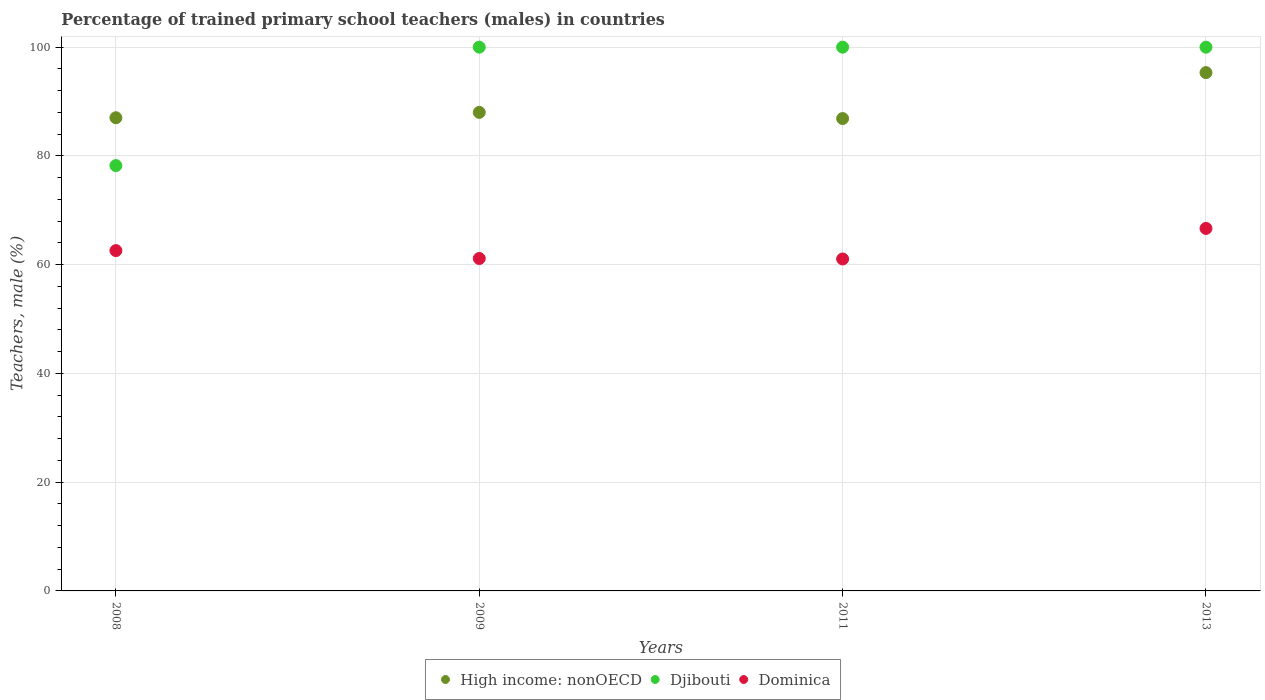Is the number of dotlines equal to the number of legend labels?
Your answer should be compact. Yes. What is the percentage of trained primary school teachers (males) in Dominica in 2008?
Make the answer very short. 62.59. Across all years, what is the maximum percentage of trained primary school teachers (males) in High income: nonOECD?
Give a very brief answer. 95.32. Across all years, what is the minimum percentage of trained primary school teachers (males) in Dominica?
Provide a short and direct response. 61.05. In which year was the percentage of trained primary school teachers (males) in Djibouti maximum?
Provide a succinct answer. 2009. In which year was the percentage of trained primary school teachers (males) in High income: nonOECD minimum?
Keep it short and to the point. 2011. What is the total percentage of trained primary school teachers (males) in High income: nonOECD in the graph?
Make the answer very short. 357.22. What is the difference between the percentage of trained primary school teachers (males) in High income: nonOECD in 2008 and that in 2009?
Provide a succinct answer. -0.99. What is the difference between the percentage of trained primary school teachers (males) in Dominica in 2011 and the percentage of trained primary school teachers (males) in High income: nonOECD in 2009?
Your response must be concise. -26.96. What is the average percentage of trained primary school teachers (males) in Dominica per year?
Ensure brevity in your answer.  62.86. In the year 2011, what is the difference between the percentage of trained primary school teachers (males) in Djibouti and percentage of trained primary school teachers (males) in High income: nonOECD?
Provide a succinct answer. 13.13. In how many years, is the percentage of trained primary school teachers (males) in Dominica greater than 52 %?
Provide a short and direct response. 4. What is the ratio of the percentage of trained primary school teachers (males) in High income: nonOECD in 2008 to that in 2011?
Your response must be concise. 1. What is the difference between the highest and the second highest percentage of trained primary school teachers (males) in Dominica?
Ensure brevity in your answer.  4.08. What is the difference between the highest and the lowest percentage of trained primary school teachers (males) in Dominica?
Offer a very short reply. 5.62. In how many years, is the percentage of trained primary school teachers (males) in Dominica greater than the average percentage of trained primary school teachers (males) in Dominica taken over all years?
Give a very brief answer. 1. Is it the case that in every year, the sum of the percentage of trained primary school teachers (males) in Dominica and percentage of trained primary school teachers (males) in High income: nonOECD  is greater than the percentage of trained primary school teachers (males) in Djibouti?
Your response must be concise. Yes. Is the percentage of trained primary school teachers (males) in High income: nonOECD strictly greater than the percentage of trained primary school teachers (males) in Djibouti over the years?
Provide a short and direct response. No. Is the percentage of trained primary school teachers (males) in Djibouti strictly less than the percentage of trained primary school teachers (males) in High income: nonOECD over the years?
Offer a terse response. No. What is the difference between two consecutive major ticks on the Y-axis?
Your answer should be very brief. 20. Does the graph contain grids?
Offer a very short reply. Yes. Where does the legend appear in the graph?
Offer a very short reply. Bottom center. How many legend labels are there?
Provide a succinct answer. 3. How are the legend labels stacked?
Give a very brief answer. Horizontal. What is the title of the graph?
Provide a succinct answer. Percentage of trained primary school teachers (males) in countries. Does "Sweden" appear as one of the legend labels in the graph?
Your response must be concise. No. What is the label or title of the Y-axis?
Provide a succinct answer. Teachers, male (%). What is the Teachers, male (%) in High income: nonOECD in 2008?
Provide a short and direct response. 87.02. What is the Teachers, male (%) in Djibouti in 2008?
Ensure brevity in your answer.  78.22. What is the Teachers, male (%) in Dominica in 2008?
Provide a succinct answer. 62.59. What is the Teachers, male (%) of High income: nonOECD in 2009?
Offer a terse response. 88.01. What is the Teachers, male (%) of Djibouti in 2009?
Your answer should be very brief. 100. What is the Teachers, male (%) in Dominica in 2009?
Offer a very short reply. 61.14. What is the Teachers, male (%) of High income: nonOECD in 2011?
Make the answer very short. 86.87. What is the Teachers, male (%) in Dominica in 2011?
Offer a terse response. 61.05. What is the Teachers, male (%) of High income: nonOECD in 2013?
Your answer should be very brief. 95.32. What is the Teachers, male (%) of Dominica in 2013?
Your response must be concise. 66.67. Across all years, what is the maximum Teachers, male (%) of High income: nonOECD?
Offer a very short reply. 95.32. Across all years, what is the maximum Teachers, male (%) of Djibouti?
Your answer should be very brief. 100. Across all years, what is the maximum Teachers, male (%) in Dominica?
Offer a terse response. 66.67. Across all years, what is the minimum Teachers, male (%) of High income: nonOECD?
Offer a terse response. 86.87. Across all years, what is the minimum Teachers, male (%) in Djibouti?
Your response must be concise. 78.22. Across all years, what is the minimum Teachers, male (%) of Dominica?
Provide a short and direct response. 61.05. What is the total Teachers, male (%) in High income: nonOECD in the graph?
Make the answer very short. 357.22. What is the total Teachers, male (%) in Djibouti in the graph?
Keep it short and to the point. 378.22. What is the total Teachers, male (%) of Dominica in the graph?
Provide a short and direct response. 251.44. What is the difference between the Teachers, male (%) in High income: nonOECD in 2008 and that in 2009?
Give a very brief answer. -0.99. What is the difference between the Teachers, male (%) in Djibouti in 2008 and that in 2009?
Keep it short and to the point. -21.78. What is the difference between the Teachers, male (%) of Dominica in 2008 and that in 2009?
Your answer should be very brief. 1.45. What is the difference between the Teachers, male (%) of High income: nonOECD in 2008 and that in 2011?
Give a very brief answer. 0.15. What is the difference between the Teachers, male (%) in Djibouti in 2008 and that in 2011?
Provide a short and direct response. -21.78. What is the difference between the Teachers, male (%) in Dominica in 2008 and that in 2011?
Offer a very short reply. 1.54. What is the difference between the Teachers, male (%) in High income: nonOECD in 2008 and that in 2013?
Your response must be concise. -8.3. What is the difference between the Teachers, male (%) in Djibouti in 2008 and that in 2013?
Ensure brevity in your answer.  -21.78. What is the difference between the Teachers, male (%) of Dominica in 2008 and that in 2013?
Make the answer very short. -4.08. What is the difference between the Teachers, male (%) in High income: nonOECD in 2009 and that in 2011?
Provide a short and direct response. 1.13. What is the difference between the Teachers, male (%) in Djibouti in 2009 and that in 2011?
Offer a very short reply. 0. What is the difference between the Teachers, male (%) of Dominica in 2009 and that in 2011?
Make the answer very short. 0.09. What is the difference between the Teachers, male (%) of High income: nonOECD in 2009 and that in 2013?
Give a very brief answer. -7.32. What is the difference between the Teachers, male (%) in Djibouti in 2009 and that in 2013?
Make the answer very short. 0. What is the difference between the Teachers, male (%) in Dominica in 2009 and that in 2013?
Provide a short and direct response. -5.53. What is the difference between the Teachers, male (%) in High income: nonOECD in 2011 and that in 2013?
Keep it short and to the point. -8.45. What is the difference between the Teachers, male (%) of Djibouti in 2011 and that in 2013?
Give a very brief answer. 0. What is the difference between the Teachers, male (%) of Dominica in 2011 and that in 2013?
Your answer should be very brief. -5.62. What is the difference between the Teachers, male (%) in High income: nonOECD in 2008 and the Teachers, male (%) in Djibouti in 2009?
Provide a short and direct response. -12.98. What is the difference between the Teachers, male (%) in High income: nonOECD in 2008 and the Teachers, male (%) in Dominica in 2009?
Provide a succinct answer. 25.88. What is the difference between the Teachers, male (%) of Djibouti in 2008 and the Teachers, male (%) of Dominica in 2009?
Offer a terse response. 17.08. What is the difference between the Teachers, male (%) of High income: nonOECD in 2008 and the Teachers, male (%) of Djibouti in 2011?
Provide a succinct answer. -12.98. What is the difference between the Teachers, male (%) of High income: nonOECD in 2008 and the Teachers, male (%) of Dominica in 2011?
Offer a terse response. 25.97. What is the difference between the Teachers, male (%) of Djibouti in 2008 and the Teachers, male (%) of Dominica in 2011?
Give a very brief answer. 17.17. What is the difference between the Teachers, male (%) in High income: nonOECD in 2008 and the Teachers, male (%) in Djibouti in 2013?
Offer a terse response. -12.98. What is the difference between the Teachers, male (%) in High income: nonOECD in 2008 and the Teachers, male (%) in Dominica in 2013?
Provide a short and direct response. 20.35. What is the difference between the Teachers, male (%) of Djibouti in 2008 and the Teachers, male (%) of Dominica in 2013?
Your response must be concise. 11.55. What is the difference between the Teachers, male (%) of High income: nonOECD in 2009 and the Teachers, male (%) of Djibouti in 2011?
Make the answer very short. -11.99. What is the difference between the Teachers, male (%) in High income: nonOECD in 2009 and the Teachers, male (%) in Dominica in 2011?
Ensure brevity in your answer.  26.96. What is the difference between the Teachers, male (%) in Djibouti in 2009 and the Teachers, male (%) in Dominica in 2011?
Offer a very short reply. 38.95. What is the difference between the Teachers, male (%) of High income: nonOECD in 2009 and the Teachers, male (%) of Djibouti in 2013?
Offer a very short reply. -11.99. What is the difference between the Teachers, male (%) in High income: nonOECD in 2009 and the Teachers, male (%) in Dominica in 2013?
Give a very brief answer. 21.34. What is the difference between the Teachers, male (%) of Djibouti in 2009 and the Teachers, male (%) of Dominica in 2013?
Provide a short and direct response. 33.33. What is the difference between the Teachers, male (%) in High income: nonOECD in 2011 and the Teachers, male (%) in Djibouti in 2013?
Give a very brief answer. -13.13. What is the difference between the Teachers, male (%) in High income: nonOECD in 2011 and the Teachers, male (%) in Dominica in 2013?
Your answer should be very brief. 20.21. What is the difference between the Teachers, male (%) of Djibouti in 2011 and the Teachers, male (%) of Dominica in 2013?
Offer a terse response. 33.33. What is the average Teachers, male (%) in High income: nonOECD per year?
Your answer should be compact. 89.31. What is the average Teachers, male (%) of Djibouti per year?
Provide a succinct answer. 94.56. What is the average Teachers, male (%) of Dominica per year?
Your answer should be very brief. 62.86. In the year 2008, what is the difference between the Teachers, male (%) of High income: nonOECD and Teachers, male (%) of Djibouti?
Your answer should be very brief. 8.8. In the year 2008, what is the difference between the Teachers, male (%) of High income: nonOECD and Teachers, male (%) of Dominica?
Make the answer very short. 24.43. In the year 2008, what is the difference between the Teachers, male (%) of Djibouti and Teachers, male (%) of Dominica?
Ensure brevity in your answer.  15.63. In the year 2009, what is the difference between the Teachers, male (%) of High income: nonOECD and Teachers, male (%) of Djibouti?
Give a very brief answer. -11.99. In the year 2009, what is the difference between the Teachers, male (%) in High income: nonOECD and Teachers, male (%) in Dominica?
Your response must be concise. 26.87. In the year 2009, what is the difference between the Teachers, male (%) in Djibouti and Teachers, male (%) in Dominica?
Make the answer very short. 38.86. In the year 2011, what is the difference between the Teachers, male (%) in High income: nonOECD and Teachers, male (%) in Djibouti?
Ensure brevity in your answer.  -13.13. In the year 2011, what is the difference between the Teachers, male (%) in High income: nonOECD and Teachers, male (%) in Dominica?
Your answer should be compact. 25.82. In the year 2011, what is the difference between the Teachers, male (%) of Djibouti and Teachers, male (%) of Dominica?
Your answer should be compact. 38.95. In the year 2013, what is the difference between the Teachers, male (%) in High income: nonOECD and Teachers, male (%) in Djibouti?
Offer a very short reply. -4.68. In the year 2013, what is the difference between the Teachers, male (%) of High income: nonOECD and Teachers, male (%) of Dominica?
Offer a very short reply. 28.65. In the year 2013, what is the difference between the Teachers, male (%) in Djibouti and Teachers, male (%) in Dominica?
Make the answer very short. 33.33. What is the ratio of the Teachers, male (%) in High income: nonOECD in 2008 to that in 2009?
Make the answer very short. 0.99. What is the ratio of the Teachers, male (%) in Djibouti in 2008 to that in 2009?
Provide a succinct answer. 0.78. What is the ratio of the Teachers, male (%) in Dominica in 2008 to that in 2009?
Make the answer very short. 1.02. What is the ratio of the Teachers, male (%) in High income: nonOECD in 2008 to that in 2011?
Keep it short and to the point. 1. What is the ratio of the Teachers, male (%) in Djibouti in 2008 to that in 2011?
Your answer should be very brief. 0.78. What is the ratio of the Teachers, male (%) in Dominica in 2008 to that in 2011?
Ensure brevity in your answer.  1.03. What is the ratio of the Teachers, male (%) in High income: nonOECD in 2008 to that in 2013?
Give a very brief answer. 0.91. What is the ratio of the Teachers, male (%) of Djibouti in 2008 to that in 2013?
Ensure brevity in your answer.  0.78. What is the ratio of the Teachers, male (%) of Dominica in 2008 to that in 2013?
Ensure brevity in your answer.  0.94. What is the ratio of the Teachers, male (%) in High income: nonOECD in 2009 to that in 2011?
Give a very brief answer. 1.01. What is the ratio of the Teachers, male (%) of Dominica in 2009 to that in 2011?
Ensure brevity in your answer.  1. What is the ratio of the Teachers, male (%) of High income: nonOECD in 2009 to that in 2013?
Give a very brief answer. 0.92. What is the ratio of the Teachers, male (%) in Dominica in 2009 to that in 2013?
Make the answer very short. 0.92. What is the ratio of the Teachers, male (%) of High income: nonOECD in 2011 to that in 2013?
Your response must be concise. 0.91. What is the ratio of the Teachers, male (%) of Dominica in 2011 to that in 2013?
Provide a short and direct response. 0.92. What is the difference between the highest and the second highest Teachers, male (%) in High income: nonOECD?
Your response must be concise. 7.32. What is the difference between the highest and the second highest Teachers, male (%) in Djibouti?
Provide a short and direct response. 0. What is the difference between the highest and the second highest Teachers, male (%) in Dominica?
Your answer should be compact. 4.08. What is the difference between the highest and the lowest Teachers, male (%) of High income: nonOECD?
Ensure brevity in your answer.  8.45. What is the difference between the highest and the lowest Teachers, male (%) of Djibouti?
Offer a very short reply. 21.78. What is the difference between the highest and the lowest Teachers, male (%) of Dominica?
Provide a short and direct response. 5.62. 